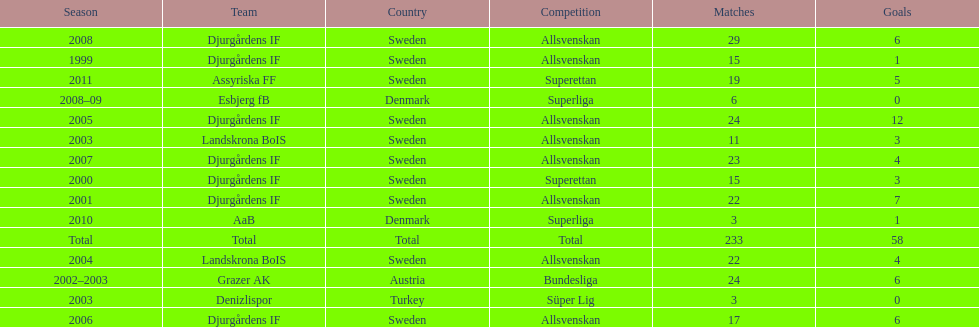What is the total number of matches? 233. 